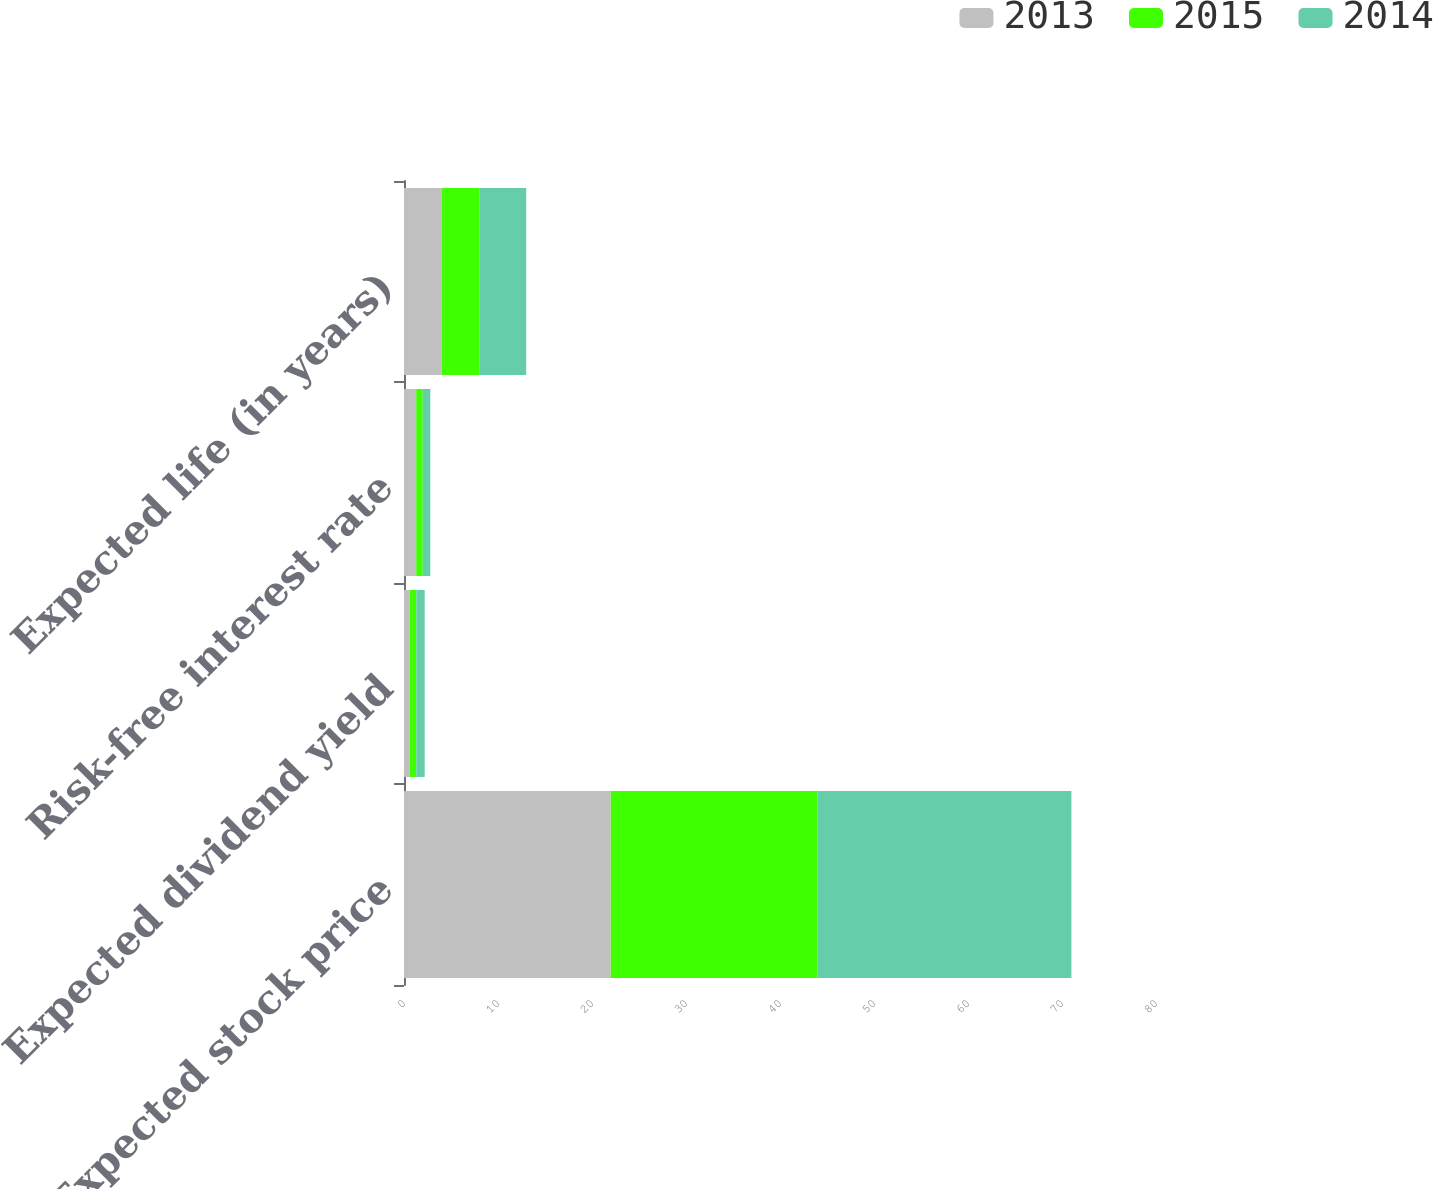Convert chart. <chart><loc_0><loc_0><loc_500><loc_500><stacked_bar_chart><ecel><fcel>Expected stock price<fcel>Expected dividend yield<fcel>Risk-free interest rate<fcel>Expected life (in years)<nl><fcel>2013<fcel>22<fcel>0.6<fcel>1.3<fcel>4<nl><fcel>2015<fcel>22<fcel>0.7<fcel>0.7<fcel>4<nl><fcel>2014<fcel>27<fcel>0.9<fcel>0.8<fcel>5<nl></chart> 